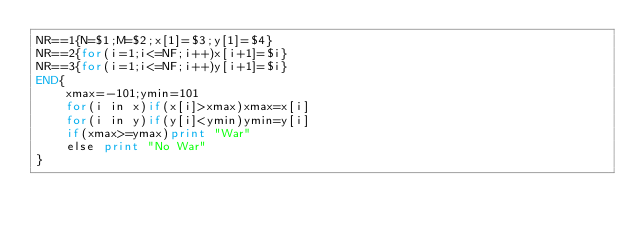Convert code to text. <code><loc_0><loc_0><loc_500><loc_500><_Awk_>NR==1{N=$1;M=$2;x[1]=$3;y[1]=$4}
NR==2{for(i=1;i<=NF;i++)x[i+1]=$i}
NR==3{for(i=1;i<=NF;i++)y[i+1]=$i}
END{
	xmax=-101;ymin=101
	for(i in x)if(x[i]>xmax)xmax=x[i]
    for(i in y)if(y[i]<ymin)ymin=y[i]
    if(xmax>=ymax)print "War"
    else print "No War"
}</code> 